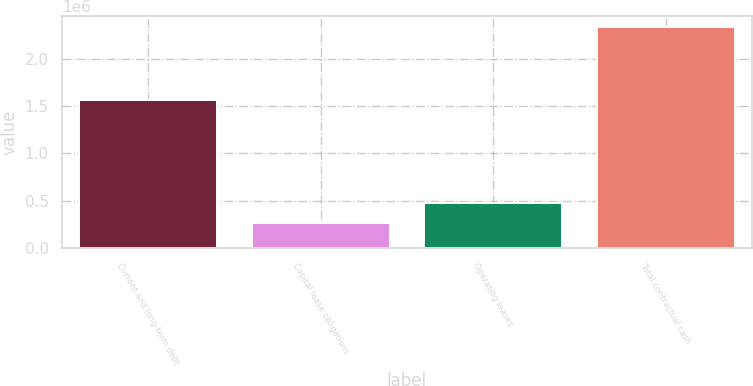<chart> <loc_0><loc_0><loc_500><loc_500><bar_chart><fcel>Current and long-term debt<fcel>Capital lease obligations<fcel>Operating leases<fcel>Total contractual cash<nl><fcel>1.56042e+06<fcel>268524<fcel>475017<fcel>2.33346e+06<nl></chart> 